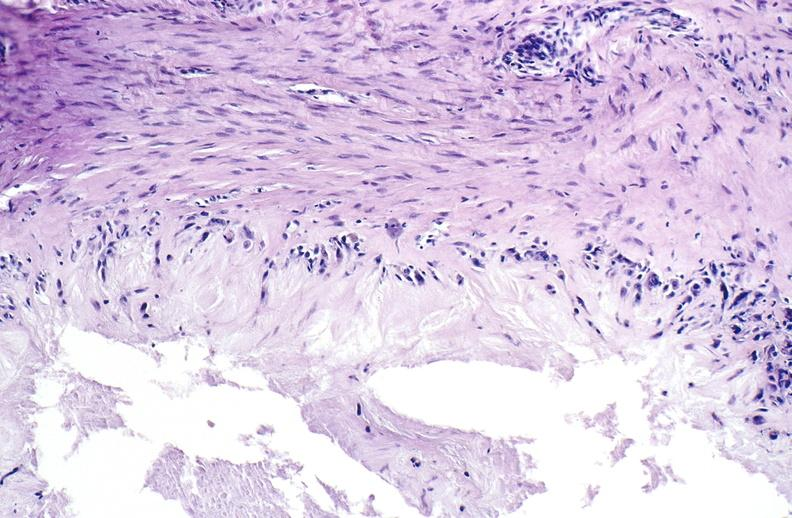does umbilical cord show gout?
Answer the question using a single word or phrase. No 